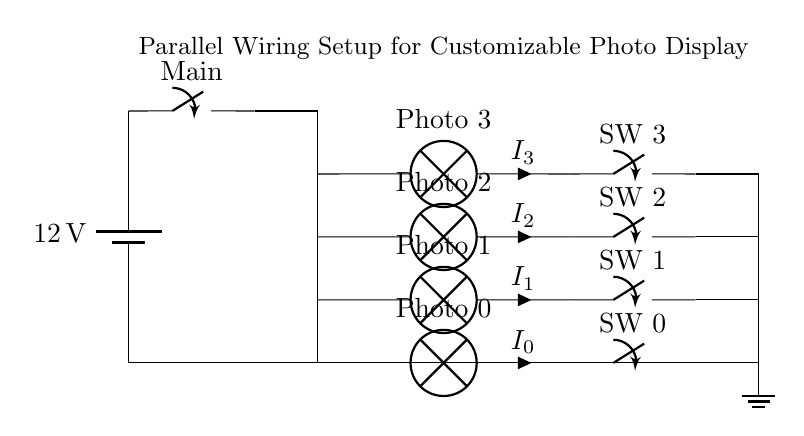What is the voltage of this circuit? The voltage across the circuit is 12 volts, as indicated by the battery symbol at the left of the diagram.
Answer: 12 volts How many photo displays are there? The circuit diagram shows four branches, each connected to a photo lamp, indicating there are four displays.
Answer: Four What type of switch is used for each display? Each display has its own individual switch, indicated by the switch symbols labeled SW 0, SW 1, SW 2, and SW 3.
Answer: Individual switches What happens when one switch is turned off? In a parallel circuit, turning off one switch will only affect the corresponding lamp, while the others will continue to operate as they are independent.
Answer: Only that lamp turns off What is the role of the main switch in this setup? The main switch controls the entire circuit, allowing the user to turn on or off all the lamps at once before they control each individual lamp.
Answer: Controls all lamps What current flows through Lamp 2? The current flowing through Lamp 2 is denoted as I subscript 2, illustrating how the current can be independently managed for each lamp in the parallel setup.
Answer: I subscript 2 